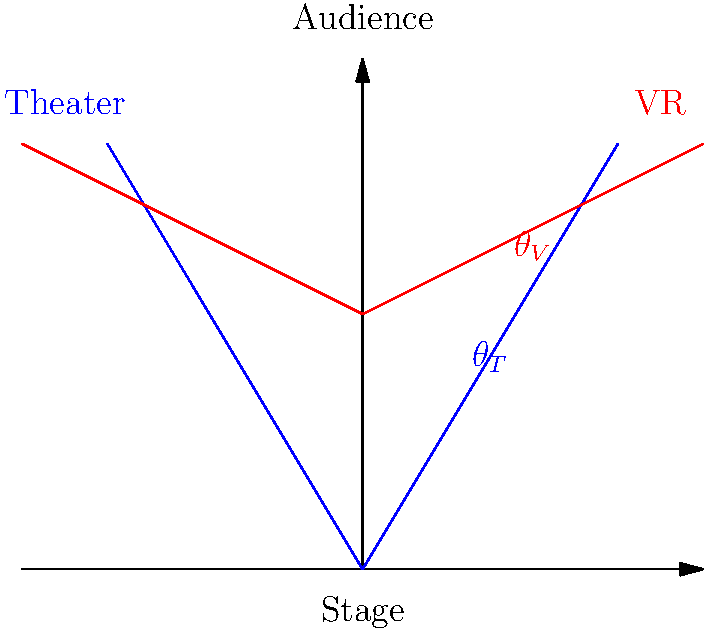In the diagram above, $\theta_T$ represents the typical viewing angle for an audience member in a traditional theater, while $\theta_V$ represents the viewing angle for a user of a virtual reality platform. If $\theta_T = 60°$ and $\theta_V = 100°$, what is the difference in the field of view between the VR experience and the traditional theater experience? To find the difference in the field of view between the VR experience and the traditional theater experience, we need to follow these steps:

1. Identify the given angles:
   - Traditional theater viewing angle: $\theta_T = 60°$
   - VR platform viewing angle: $\theta_V = 100°$

2. Calculate the difference between the two angles:
   $\text{Difference} = \theta_V - \theta_T$
   $\text{Difference} = 100° - 60°$
   $\text{Difference} = 40°$

3. Interpret the result:
   The positive difference indicates that the VR experience offers a wider field of view compared to the traditional theater experience.

This difference in viewing angles helps explain why your child might prefer virtual storytelling, as it provides a more immersive experience with a broader field of view.
Answer: 40° 